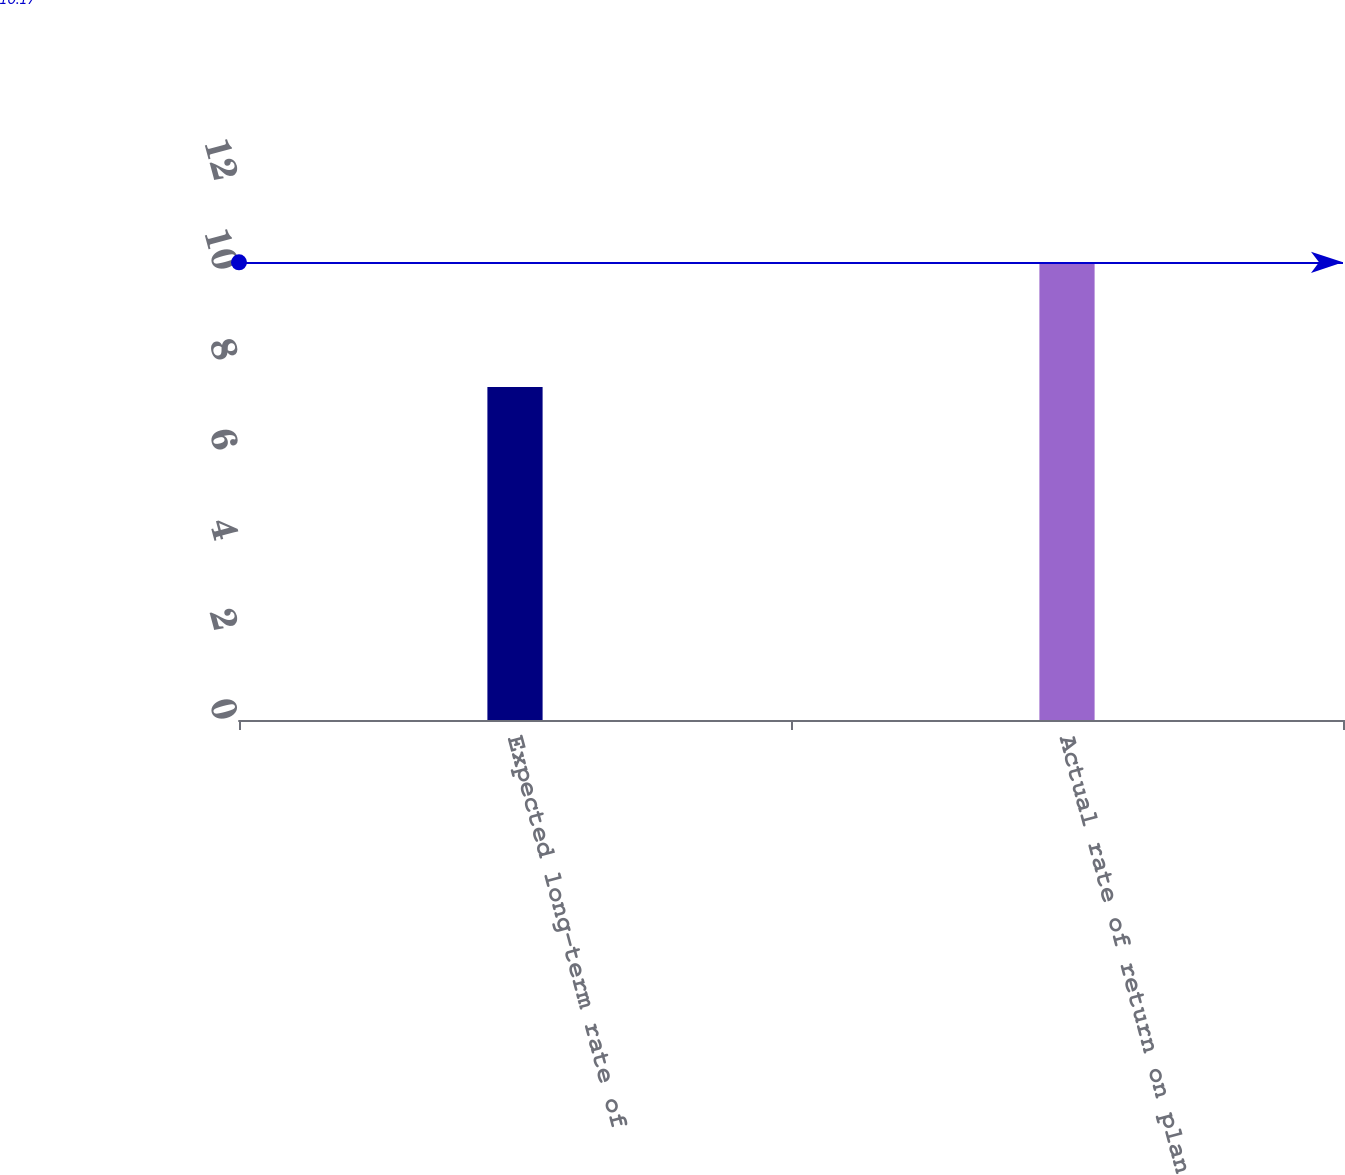Convert chart to OTSL. <chart><loc_0><loc_0><loc_500><loc_500><bar_chart><fcel>Expected long-term rate of<fcel>Actual rate of return on plan<nl><fcel>7.4<fcel>10.17<nl></chart> 